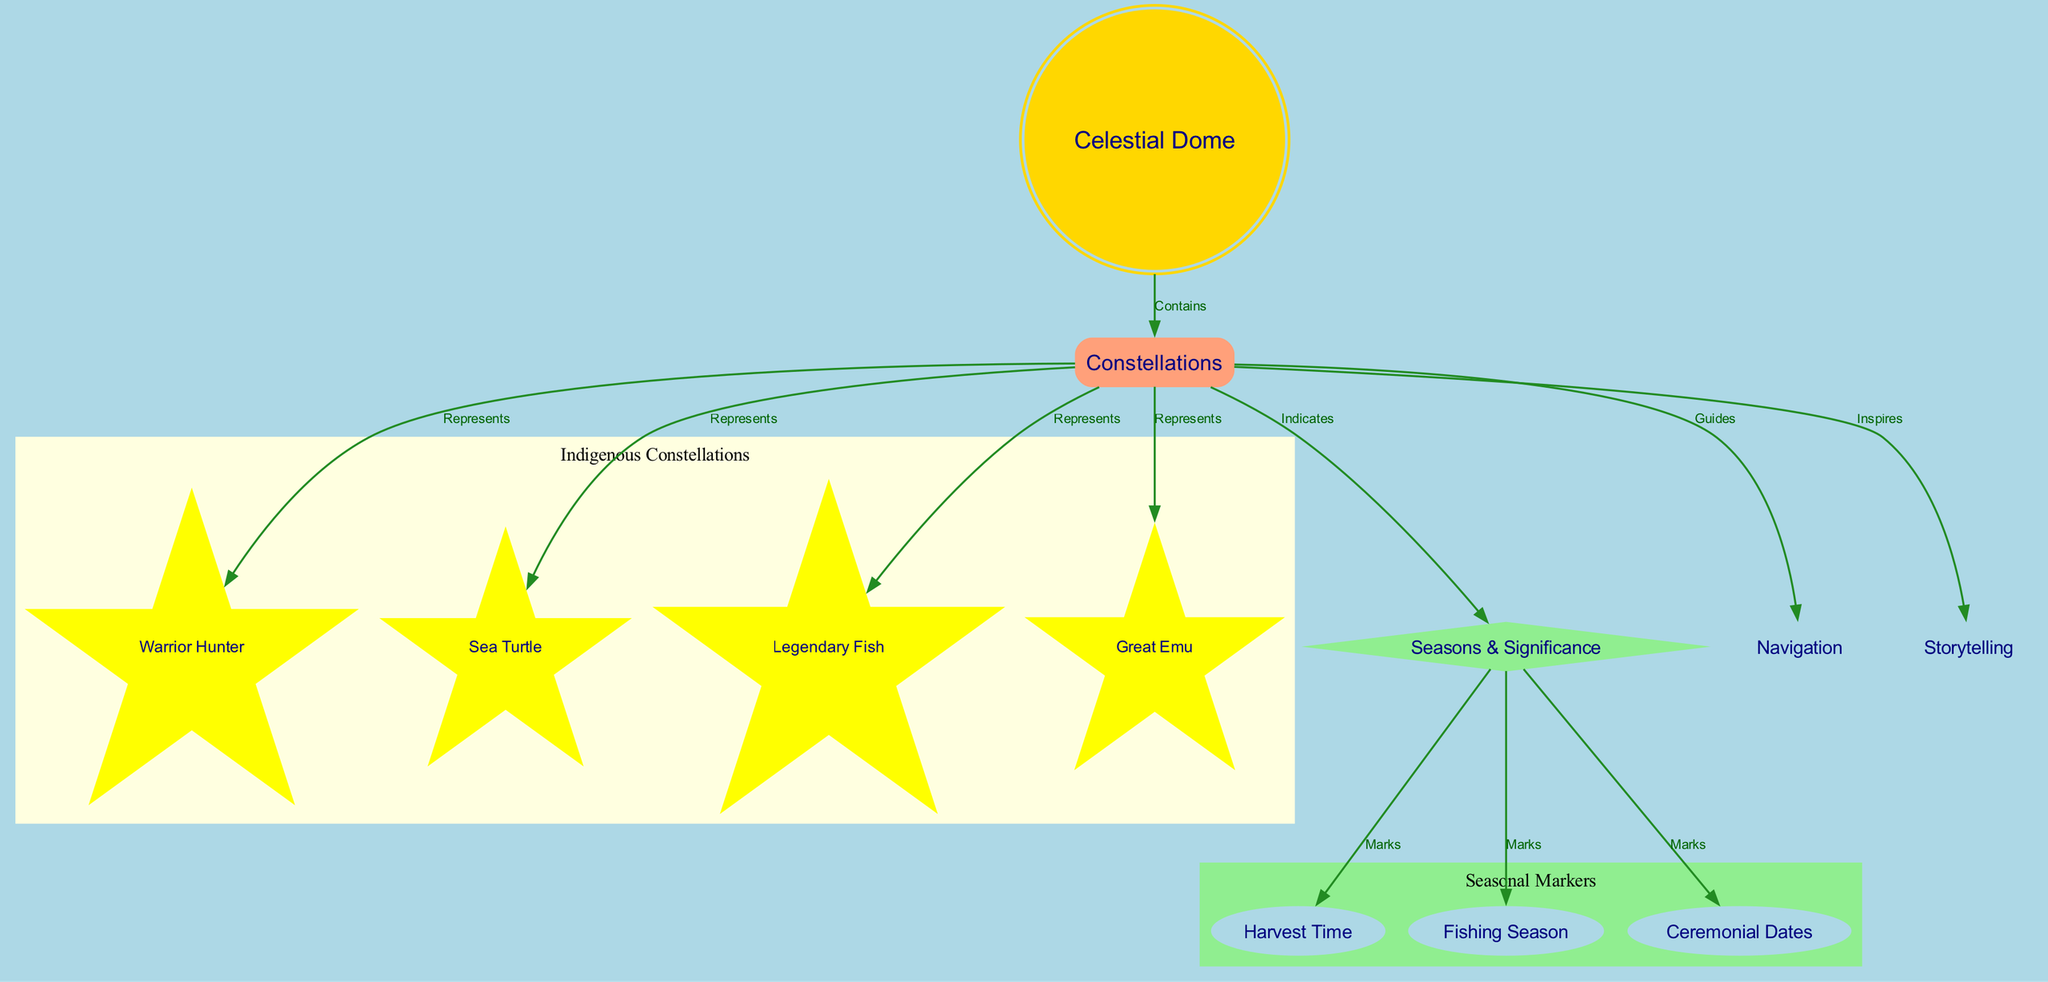What is the main title of the diagram? The title is clearly stated at the top of the diagram and reads "The Star Patterns and Their Stories: A Map of Indigenous Constellations."
Answer: The Star Patterns and Their Stories: A Map of Indigenous Constellations How many nodes are present in the diagram? By counting each individual element that is defined as a node, we find a total of 12 nodes in the diagram.
Answer: 12 What type of shape is used for "Celestial Dome"? Observing the diagram, "Celestial Dome" is represented in a double circle, which is visually distinct from other node shapes.
Answer: doublecircle Which constellations represent the "Warrior Hunter"? The edge from "constellations" to "warrior_hunter" indicates that "warrior_hunter" is one of the constellations represented.
Answer: warrior_hunter What does the "Seasons & Significance" node indicate? The edges connecting "seasons_significance" to other nodes show that it indicates various seasonal markers, such as harvest time and fishing season.
Answer: Indicates How many seasonal markers are listed? By examining the connections from "seasons_significance," we can see three specific seasonal markers: "harvest_time," "fishing_season," and "ceremonial_dates."
Answer: 3 What do constellations guide? The edge labeled "Guides" shows that constellations help with "navigation," making it clear what they are used for.
Answer: navigation Which constellations inspire storytelling? The edge labeled "Inspires" directly connects "constellations" to another node, indicating that constellations inspire "storytelling."
Answer: storytelling What color is used for the nodes related to seasonal significance? Observing the nodes, those clustered under "seasonal significance" are filled with light green color, which differentiates them from others.
Answer: lightgreen 